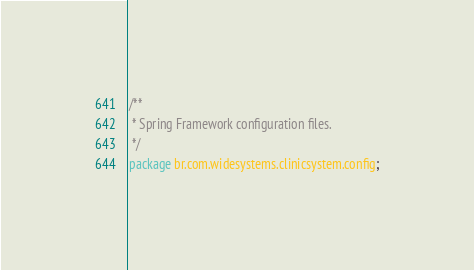<code> <loc_0><loc_0><loc_500><loc_500><_Java_>/**
 * Spring Framework configuration files.
 */
package br.com.widesystems.clinicsystem.config;
</code> 